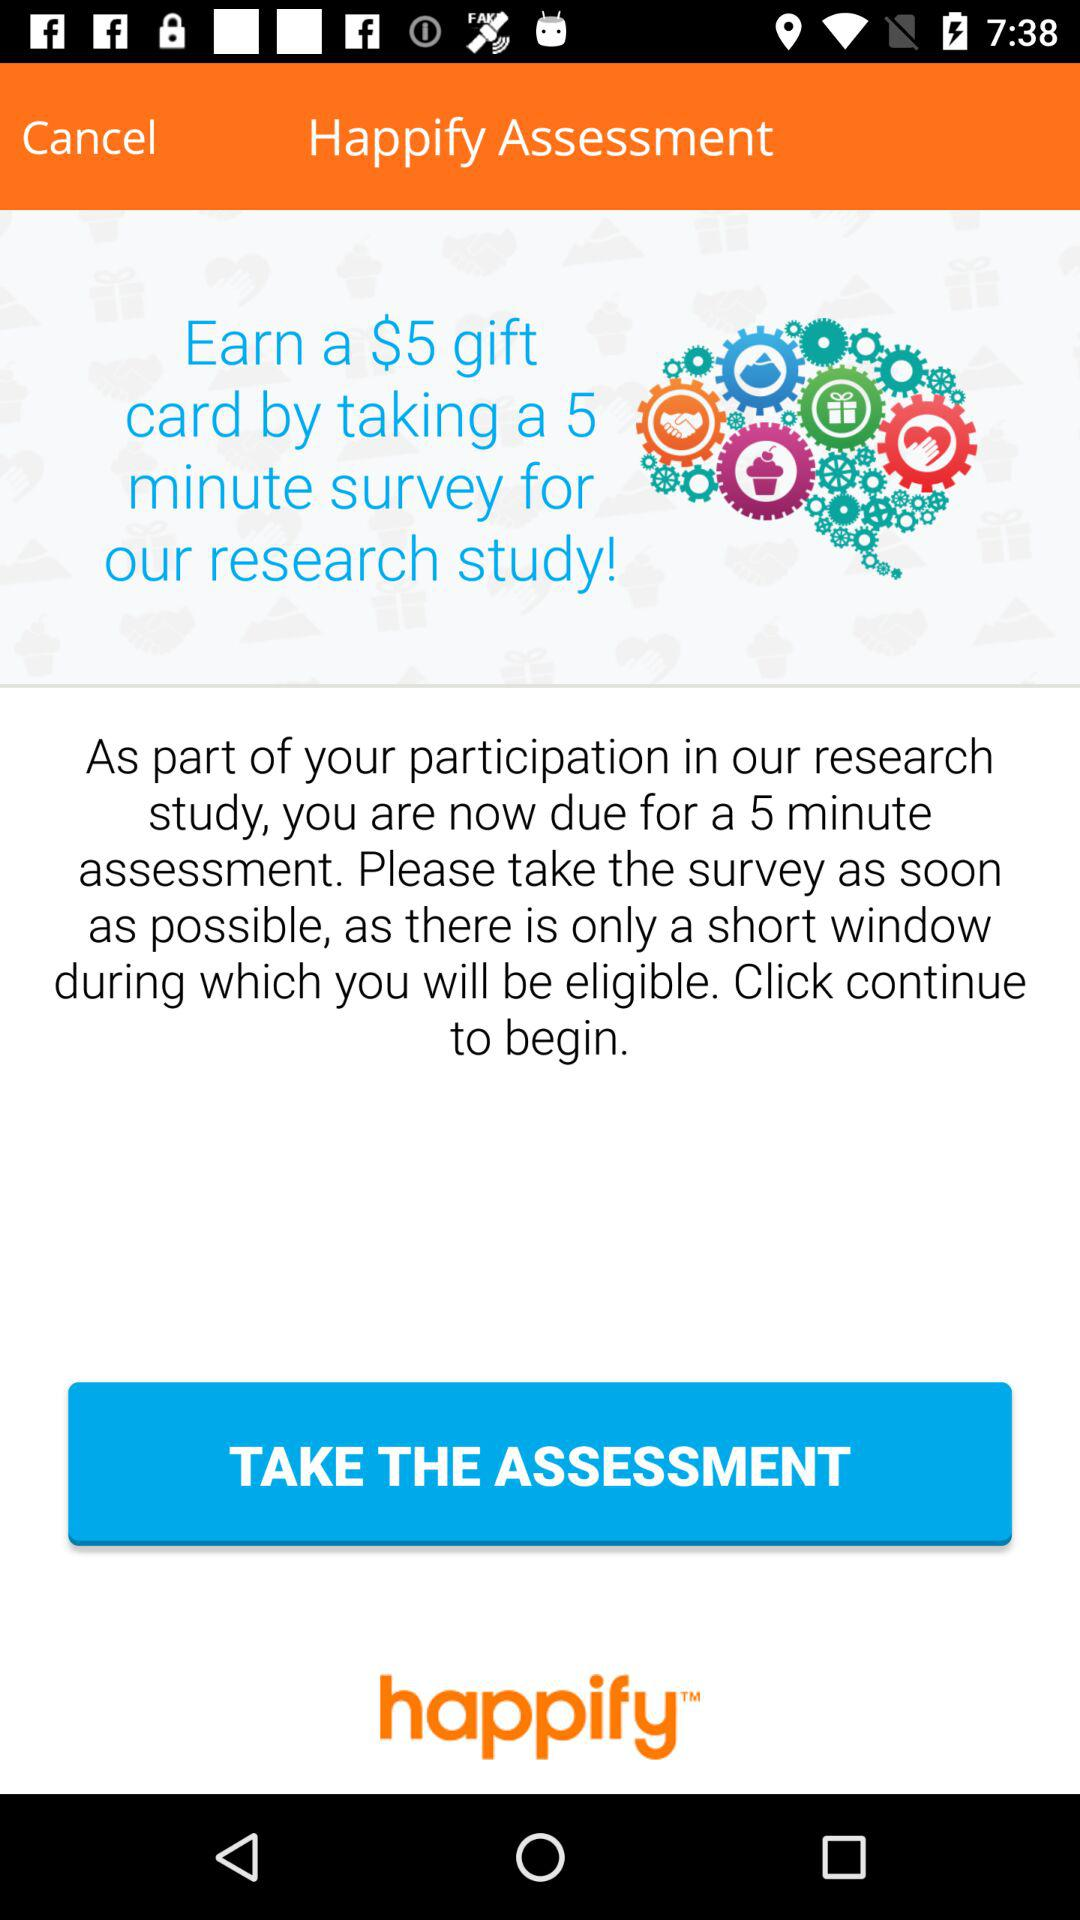What is the name of the application? The application name is "happify". 